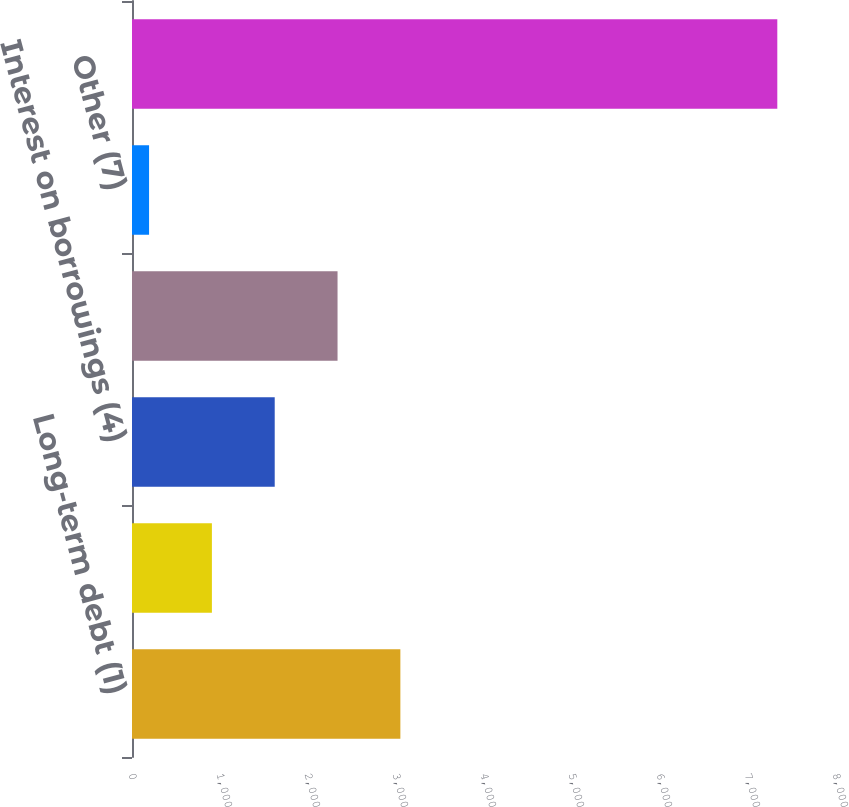Convert chart to OTSL. <chart><loc_0><loc_0><loc_500><loc_500><bar_chart><fcel>Long-term debt (1)<fcel>Other (2) (3)<fcel>Interest on borrowings (4)<fcel>Operating lease obligations<fcel>Other (7)<fcel>Total<nl><fcel>3049.6<fcel>907.9<fcel>1621.8<fcel>2335.7<fcel>194<fcel>7333<nl></chart> 